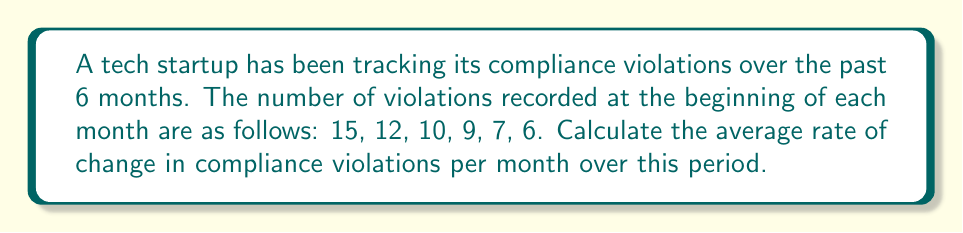Give your solution to this math problem. To calculate the average rate of change in compliance violations per month, we need to follow these steps:

1. Identify the initial and final values:
   Initial value (at month 0): $y_1 = 15$
   Final value (at month 5): $y_2 = 6$

2. Determine the time interval:
   Time interval: $x_2 - x_1 = 5$ months

3. Calculate the total change in violations:
   Total change = $y_2 - y_1 = 6 - 15 = -9$

4. Use the average rate of change formula:
   $$\text{Average rate of change} = \frac{y_2 - y_1}{x_2 - x_1} = \frac{6 - 15}{5 - 0} = \frac{-9}{5} = -1.8$$

The negative value indicates a decrease in violations over time.
Answer: $-1.8$ violations/month 